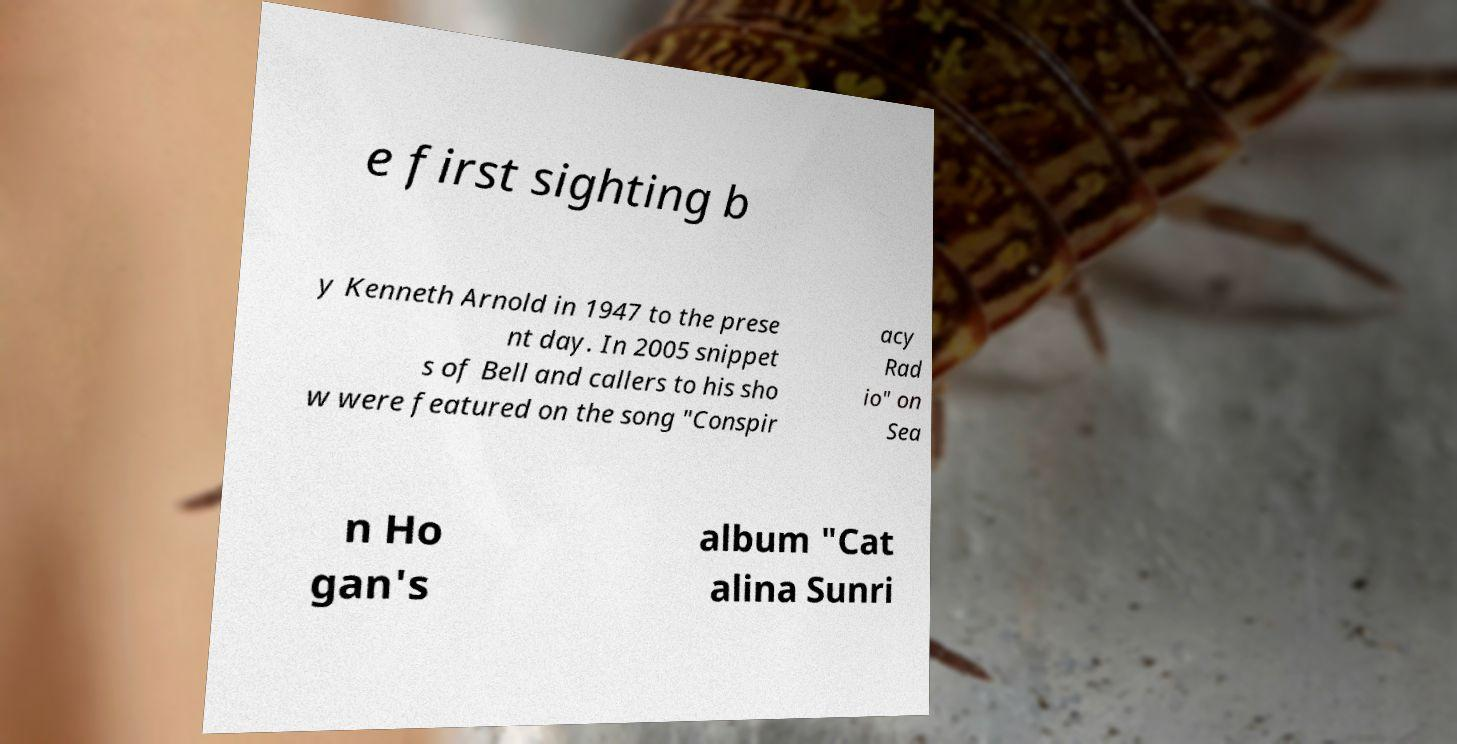Could you extract and type out the text from this image? e first sighting b y Kenneth Arnold in 1947 to the prese nt day. In 2005 snippet s of Bell and callers to his sho w were featured on the song "Conspir acy Rad io" on Sea n Ho gan's album "Cat alina Sunri 